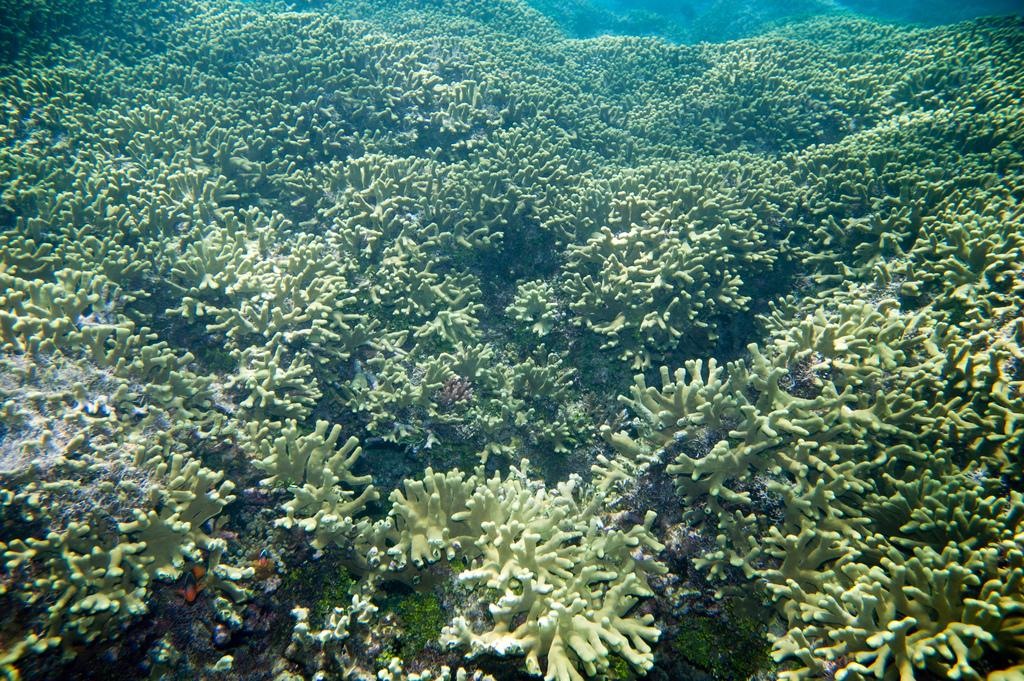What type of plants are visible in the image? There are aquatic plants in the image. What is the color of the aquatic plants? The aquatic plants are green in color. What type of knife is being used to cut the metal in the image? There is no knife or metal present in the image; it only features aquatic plants. 